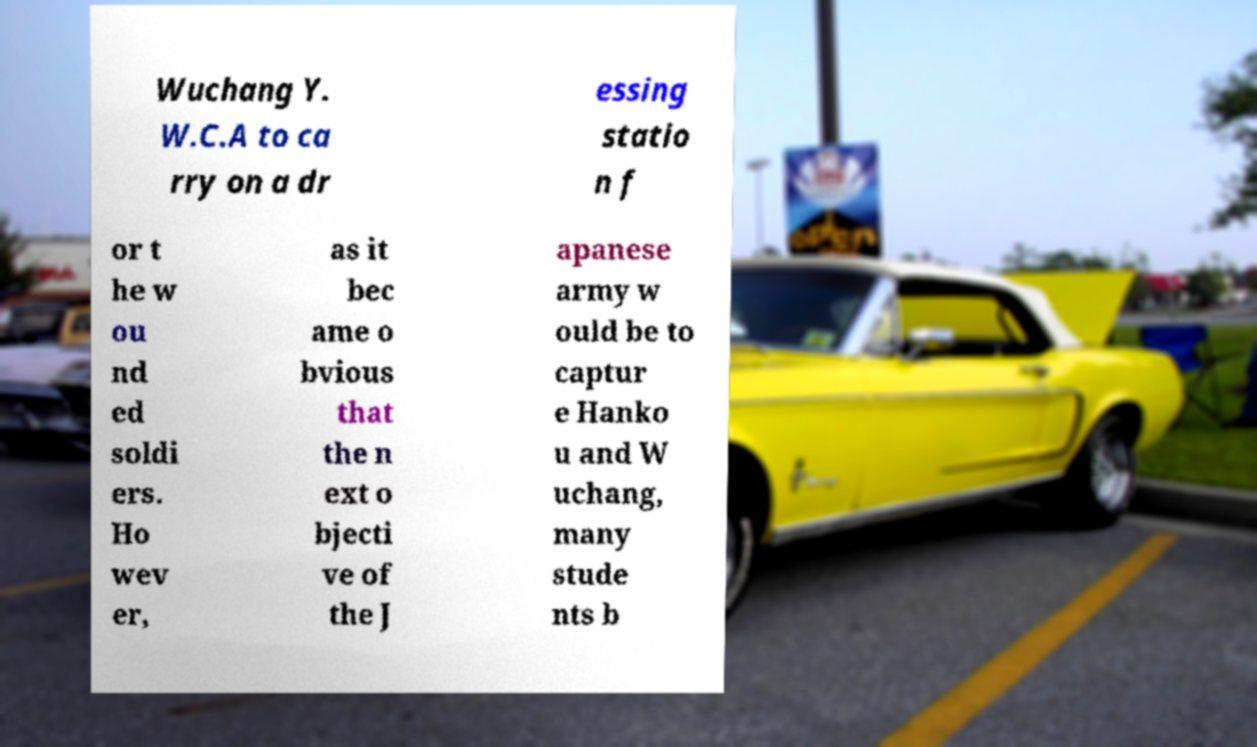Could you assist in decoding the text presented in this image and type it out clearly? Wuchang Y. W.C.A to ca rry on a dr essing statio n f or t he w ou nd ed soldi ers. Ho wev er, as it bec ame o bvious that the n ext o bjecti ve of the J apanese army w ould be to captur e Hanko u and W uchang, many stude nts b 